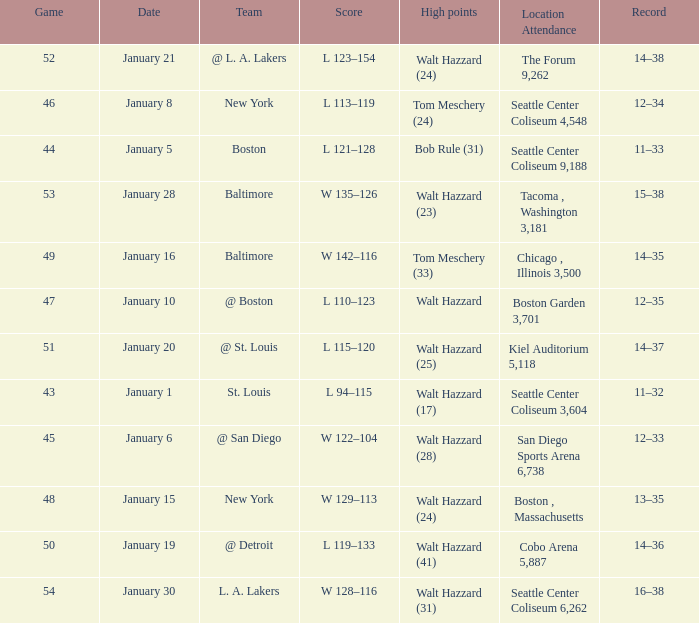What is the record for the St. Louis team? 11–32. 